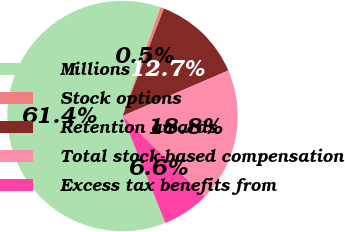Convert chart. <chart><loc_0><loc_0><loc_500><loc_500><pie_chart><fcel>Millions<fcel>Stock options<fcel>Retention awards<fcel>Total stock-based compensation<fcel>Excess tax benefits from<nl><fcel>61.4%<fcel>0.52%<fcel>12.69%<fcel>18.78%<fcel>6.61%<nl></chart> 